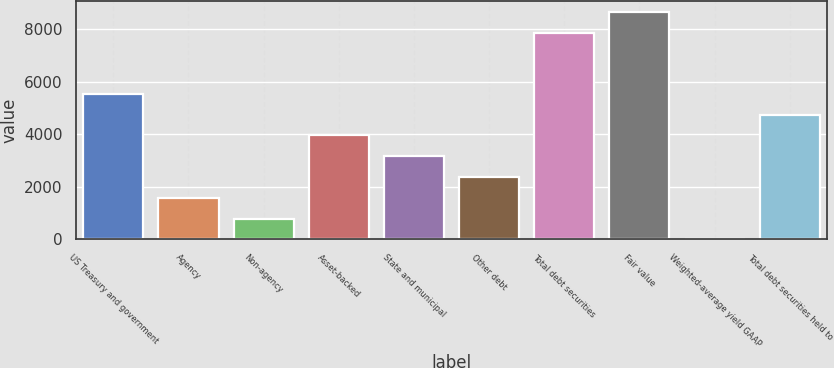Convert chart. <chart><loc_0><loc_0><loc_500><loc_500><bar_chart><fcel>US Treasury and government<fcel>Agency<fcel>Non-agency<fcel>Asset-backed<fcel>State and municipal<fcel>Other debt<fcel>Total debt securities<fcel>Fair value<fcel>Weighted-average yield GAAP<fcel>Total debt securities held to<nl><fcel>5548.87<fcel>1587.02<fcel>794.65<fcel>3964.13<fcel>3171.76<fcel>2379.39<fcel>7872<fcel>8664.37<fcel>2.28<fcel>4756.5<nl></chart> 